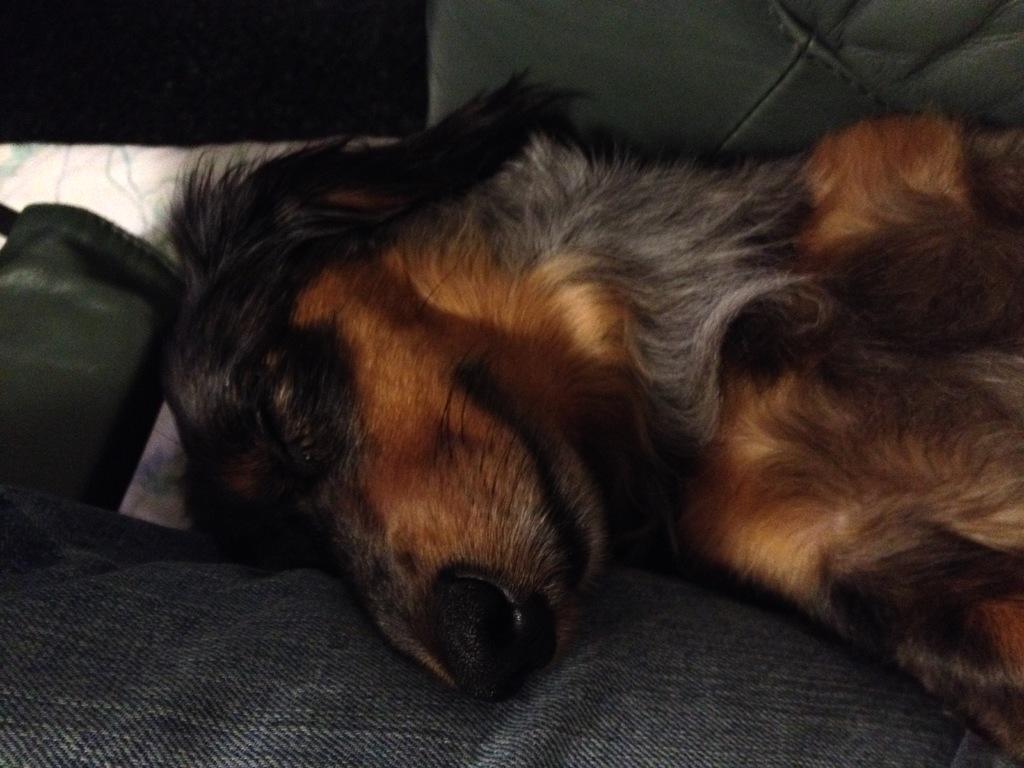Can you describe this image briefly? This picture contains a dog in brown color. This dog is lying on the bed. At the bottom of the picture, we see a black color sheet. In the background, we see a white wall and brown door. This picture is clicked inside the room. 